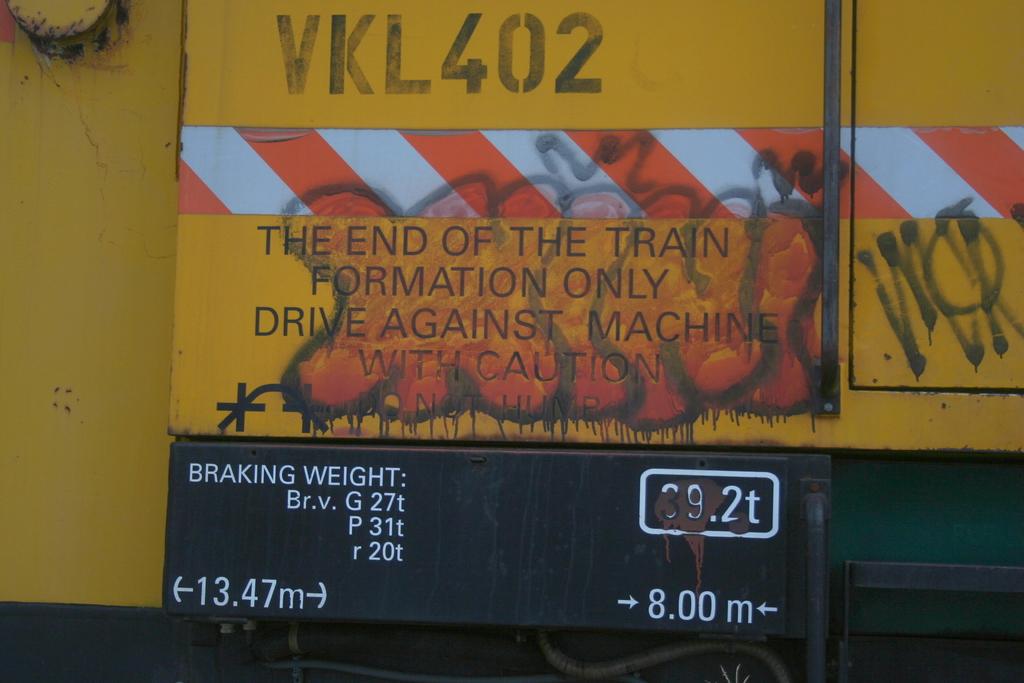What is the serial number near the top?
Provide a succinct answer. Vkl402. 